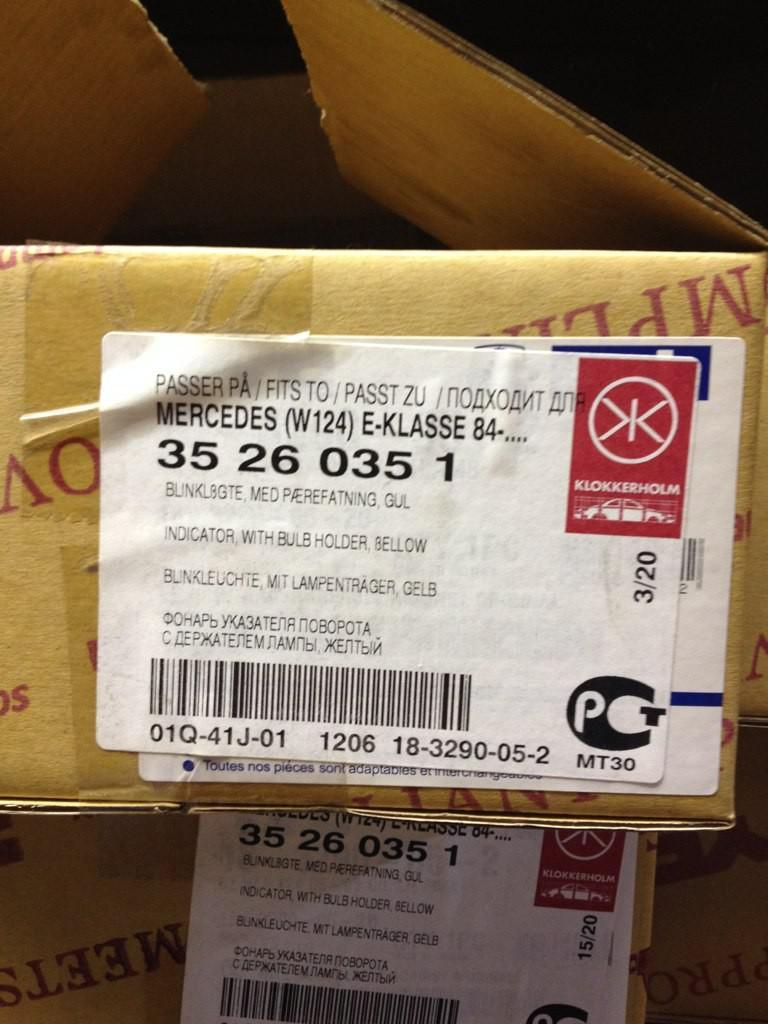Provide a one-sentence caption for the provided image. A package that has been mailed and has Mercedes on it. 